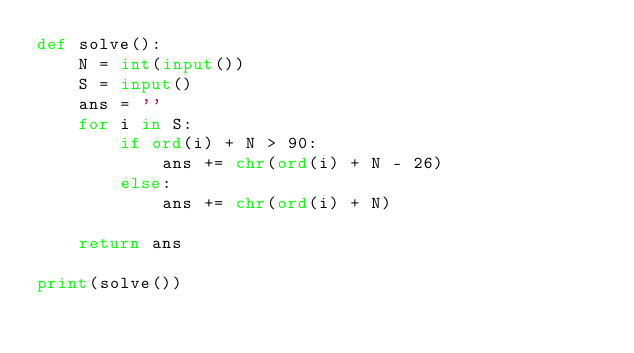Convert code to text. <code><loc_0><loc_0><loc_500><loc_500><_Python_>def solve():
    N = int(input())
    S = input()
    ans = ''
    for i in S:
        if ord(i) + N > 90:
            ans += chr(ord(i) + N - 26)
        else:
            ans += chr(ord(i) + N)

    return ans

print(solve())</code> 